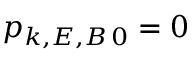Convert formula to latex. <formula><loc_0><loc_0><loc_500><loc_500>p _ { k , E , B \, 0 } = 0</formula> 